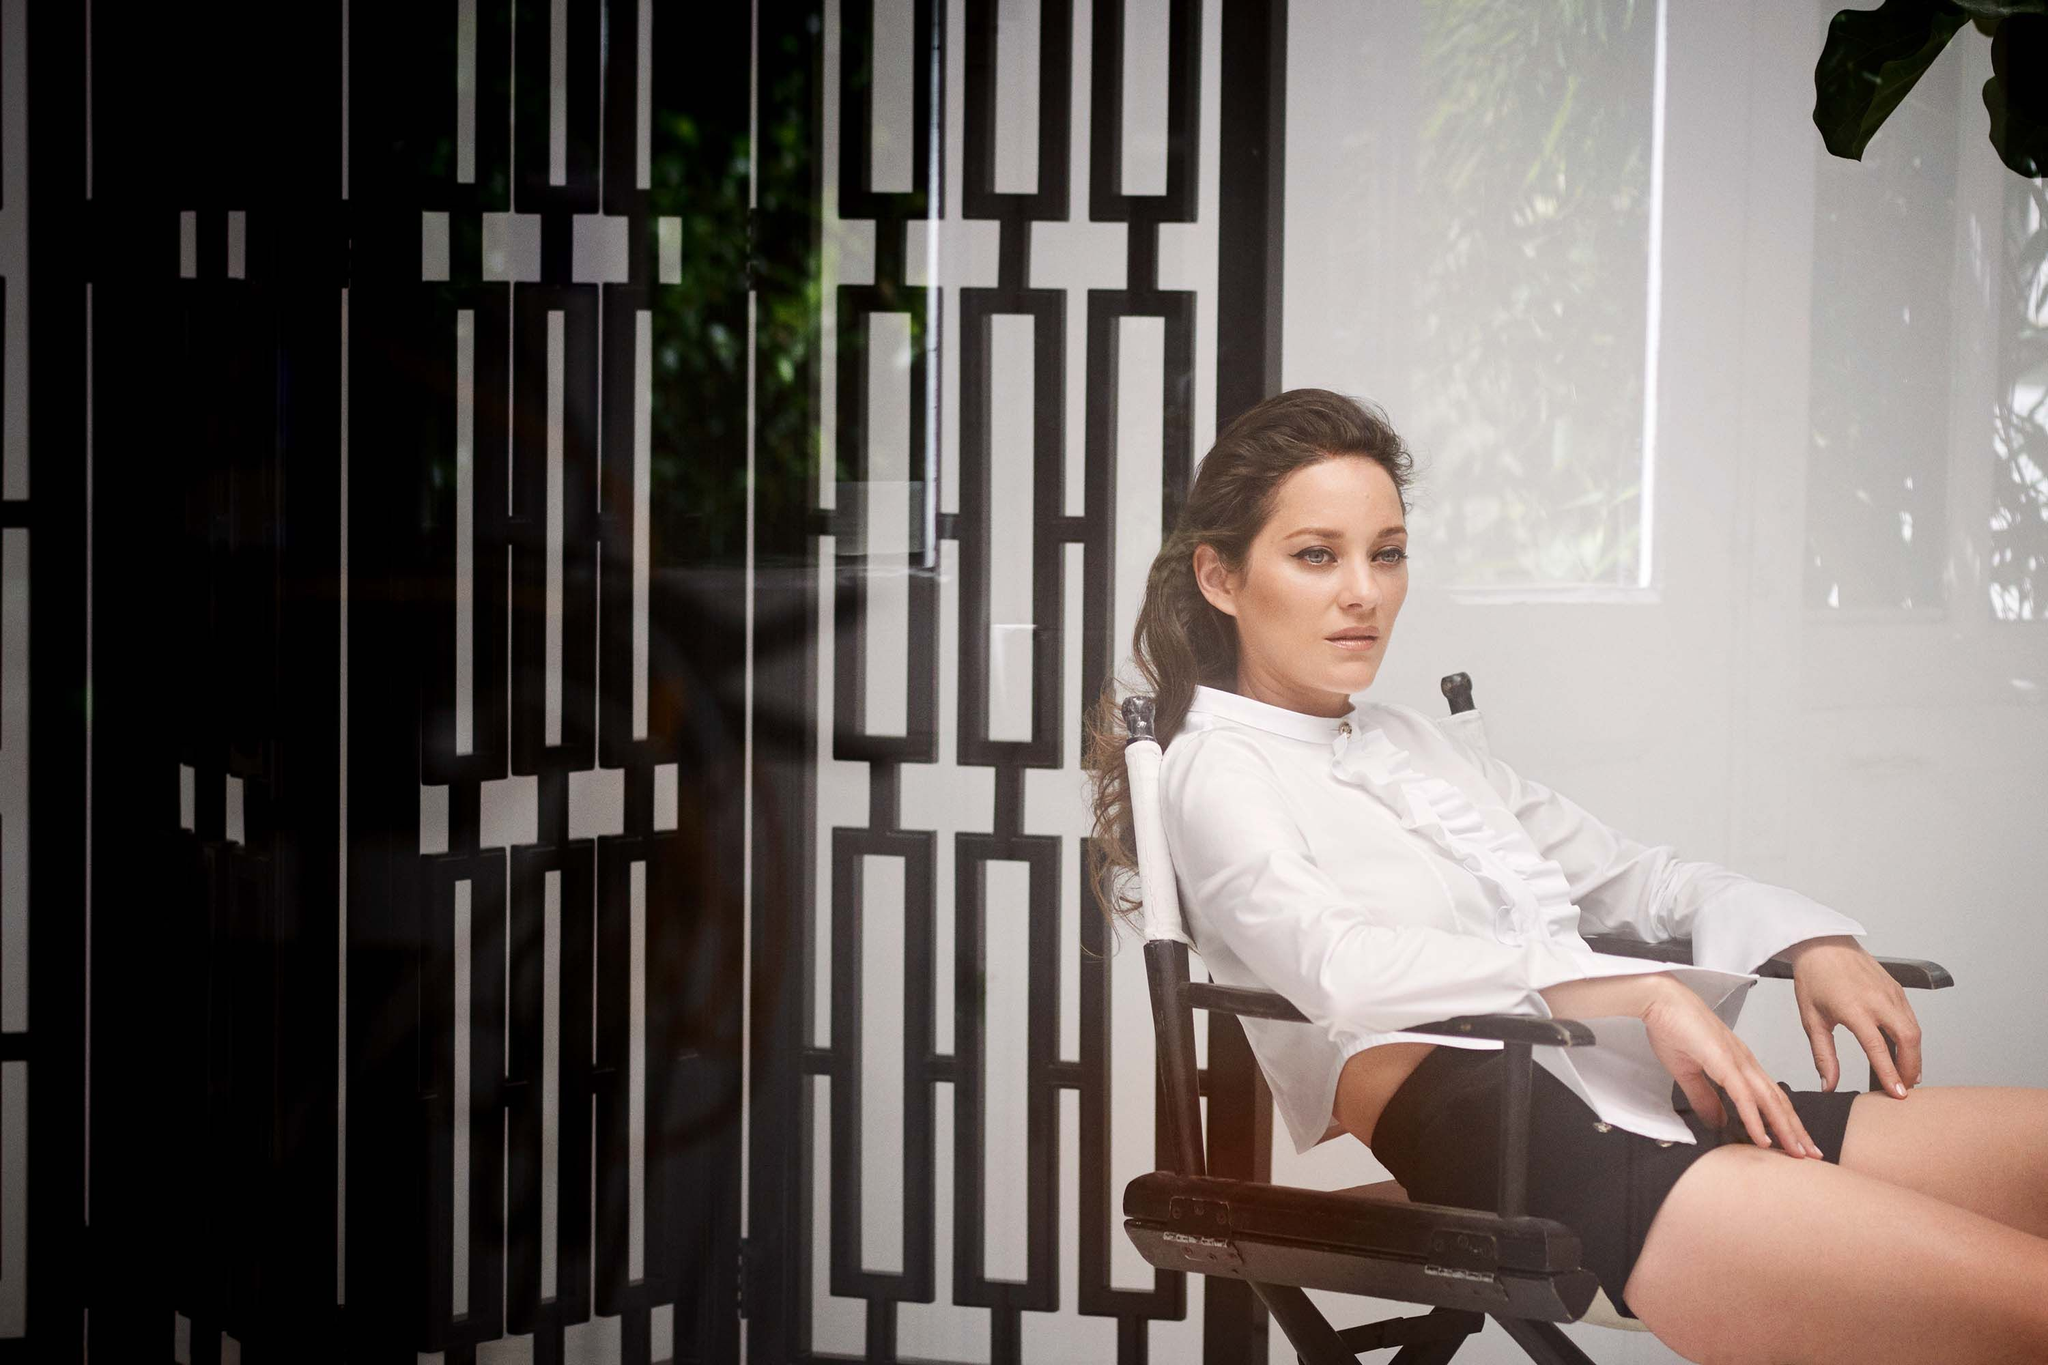What are the key elements in this picture? In this image, a woman in a moment of quiet reflection is captured. She sits on a wooden director's chair in front of a wall adorned with a black and white geometric pattern. She's dressed in a crisp white blouse paired with contrasting black shorts, maintaining the monochromatic theme. Her loose wavy hair frames her face as she gazes thoughtfully to one side. The overall scene suggests a behind-the-scenes moment, possibly taken during a break on a film set. 